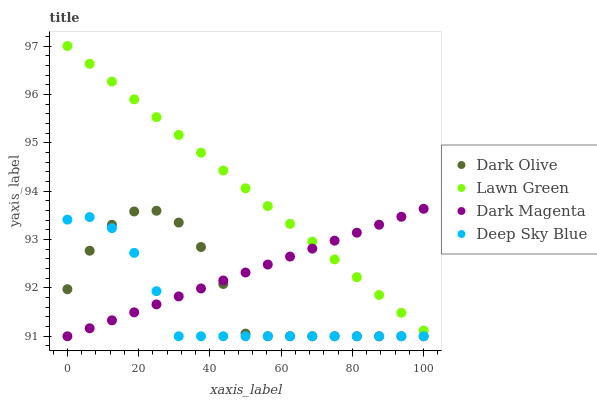Does Deep Sky Blue have the minimum area under the curve?
Answer yes or no. Yes. Does Lawn Green have the maximum area under the curve?
Answer yes or no. Yes. Does Dark Olive have the minimum area under the curve?
Answer yes or no. No. Does Dark Olive have the maximum area under the curve?
Answer yes or no. No. Is Dark Magenta the smoothest?
Answer yes or no. Yes. Is Dark Olive the roughest?
Answer yes or no. Yes. Is Dark Olive the smoothest?
Answer yes or no. No. Is Dark Magenta the roughest?
Answer yes or no. No. Does Dark Olive have the lowest value?
Answer yes or no. Yes. Does Lawn Green have the highest value?
Answer yes or no. Yes. Does Dark Olive have the highest value?
Answer yes or no. No. Is Dark Olive less than Lawn Green?
Answer yes or no. Yes. Is Lawn Green greater than Deep Sky Blue?
Answer yes or no. Yes. Does Dark Olive intersect Deep Sky Blue?
Answer yes or no. Yes. Is Dark Olive less than Deep Sky Blue?
Answer yes or no. No. Is Dark Olive greater than Deep Sky Blue?
Answer yes or no. No. Does Dark Olive intersect Lawn Green?
Answer yes or no. No. 